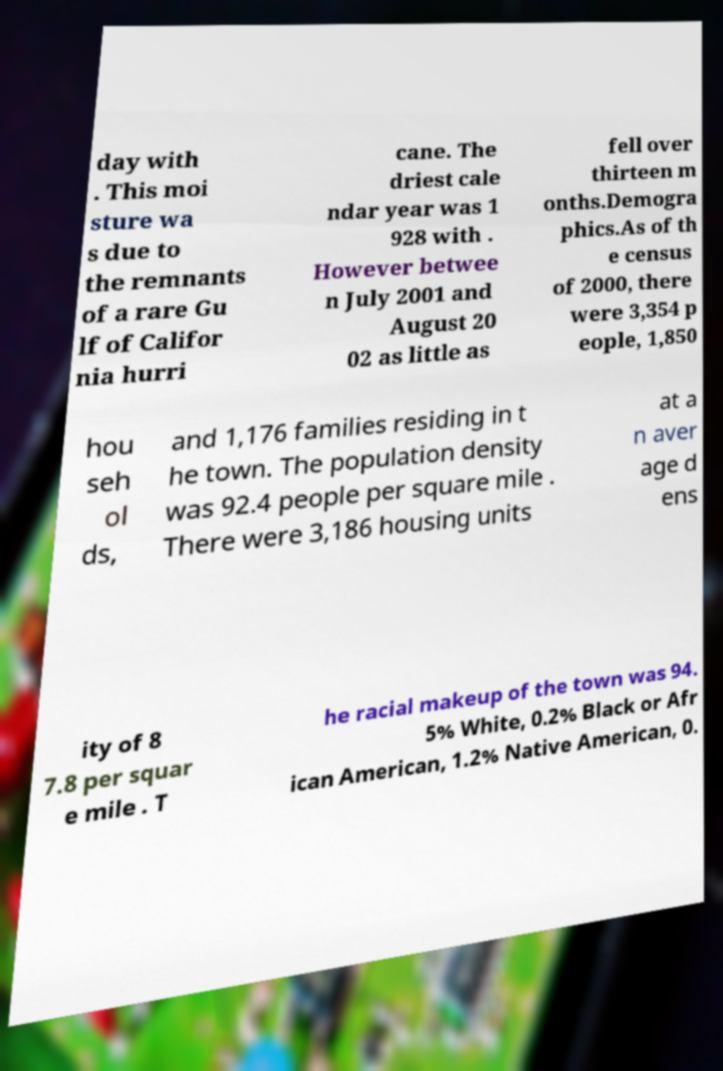What messages or text are displayed in this image? I need them in a readable, typed format. day with . This moi sture wa s due to the remnants of a rare Gu lf of Califor nia hurri cane. The driest cale ndar year was 1 928 with . However betwee n July 2001 and August 20 02 as little as fell over thirteen m onths.Demogra phics.As of th e census of 2000, there were 3,354 p eople, 1,850 hou seh ol ds, and 1,176 families residing in t he town. The population density was 92.4 people per square mile . There were 3,186 housing units at a n aver age d ens ity of 8 7.8 per squar e mile . T he racial makeup of the town was 94. 5% White, 0.2% Black or Afr ican American, 1.2% Native American, 0. 